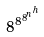<formula> <loc_0><loc_0><loc_500><loc_500>8 ^ { 8 ^ { 8 ^ { n ^ { h } } } }</formula> 